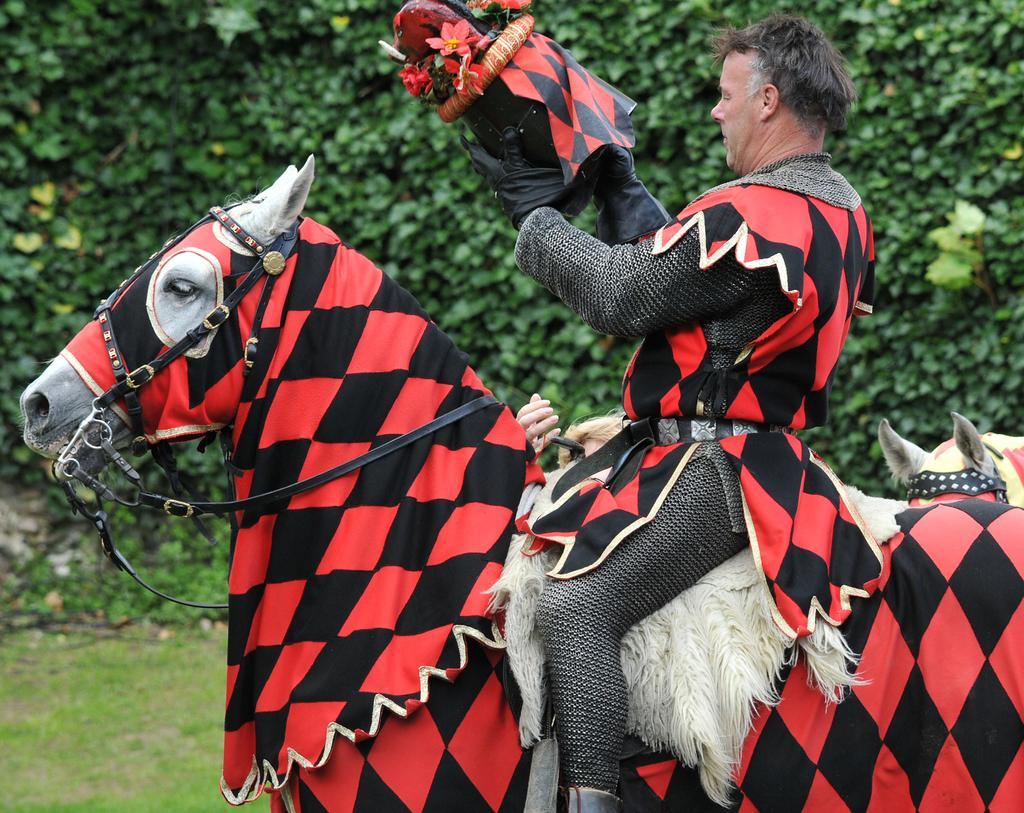Describe this image in one or two sentences. In this picture we can see a man riding a horse with some costumes, in the background we can see some trees and in the bottom we can see some grass. 